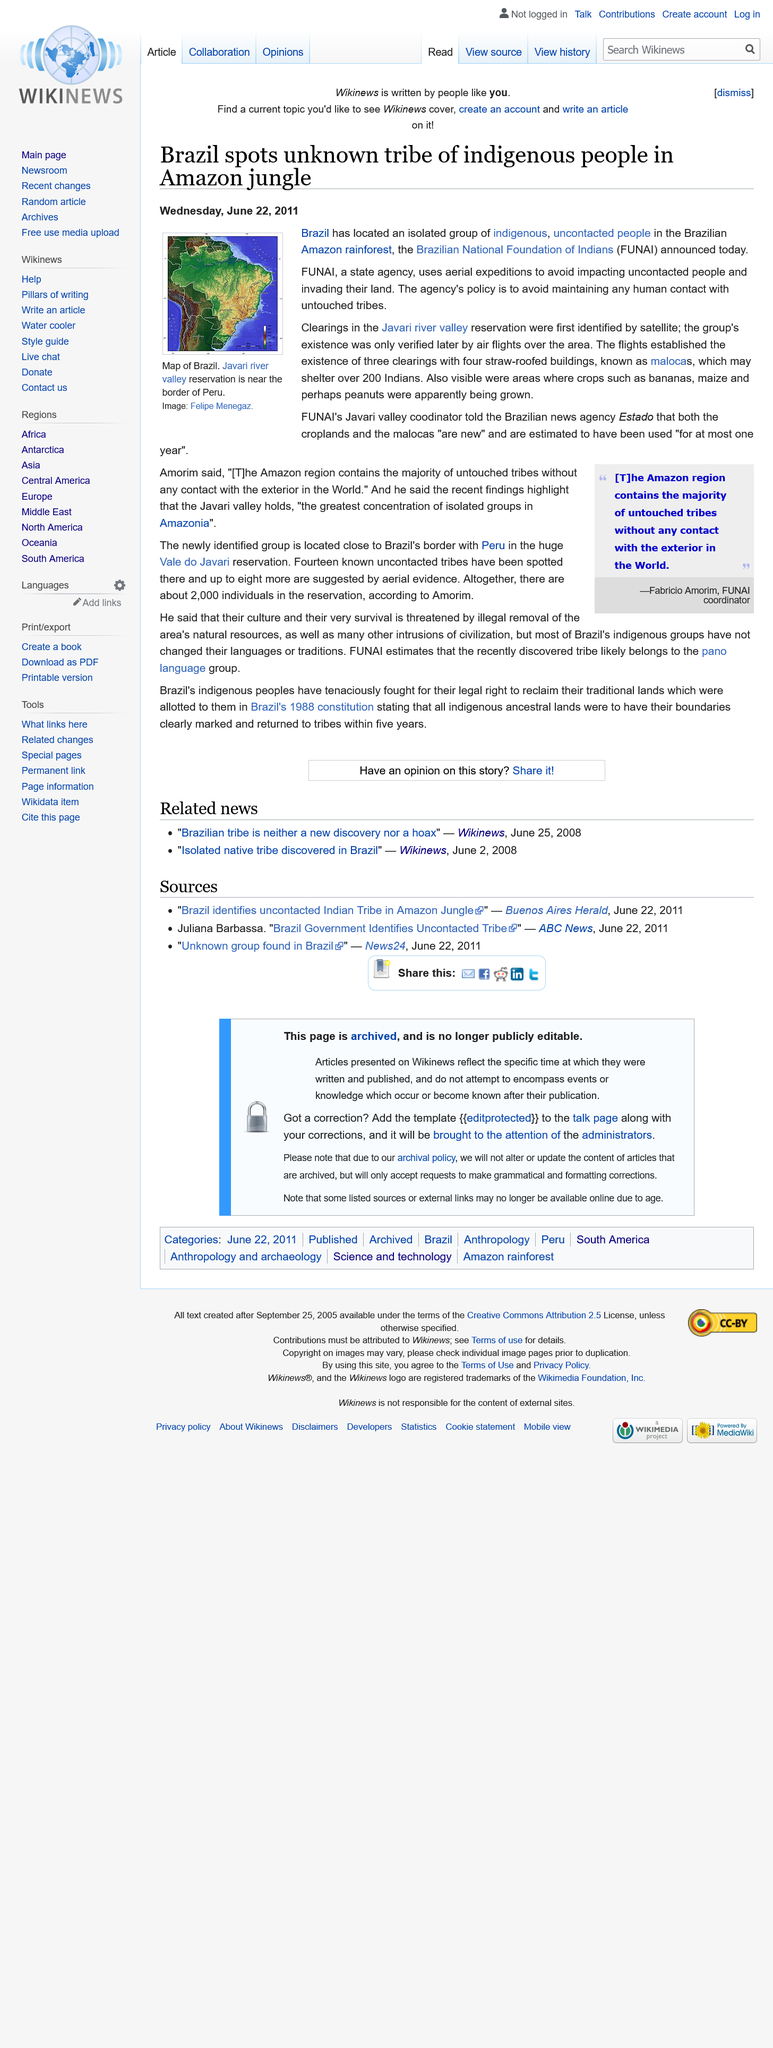Mention a couple of crucial points in this snapshot. Estado is a news agency based in Brazil that provides accurate and up-to-date information to its readers. The Javari river valley is located in Brazil. The maloca is a straw-roofed building that is used as a community gathering place. 